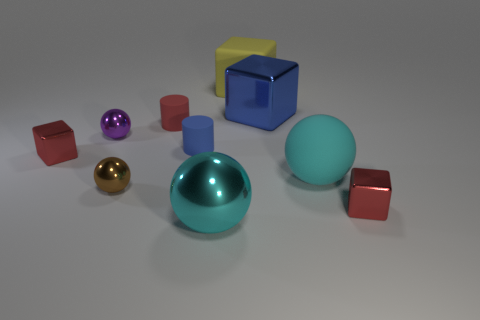Subtract all cylinders. How many objects are left? 8 Add 2 blue matte cylinders. How many blue matte cylinders exist? 3 Subtract 0 brown cylinders. How many objects are left? 10 Subtract all cyan matte things. Subtract all cyan shiny balls. How many objects are left? 8 Add 4 big cyan rubber spheres. How many big cyan rubber spheres are left? 5 